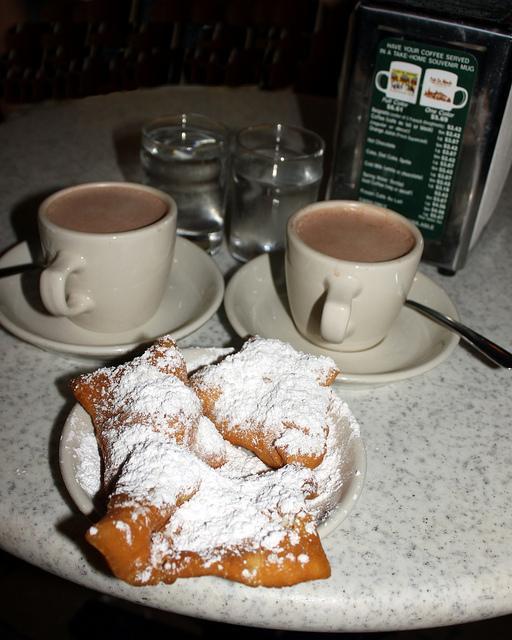What is in the tin box?
Answer the question by selecting the correct answer among the 4 following choices.
Options: Salt, pepper, sugar, napkins. Napkins. 